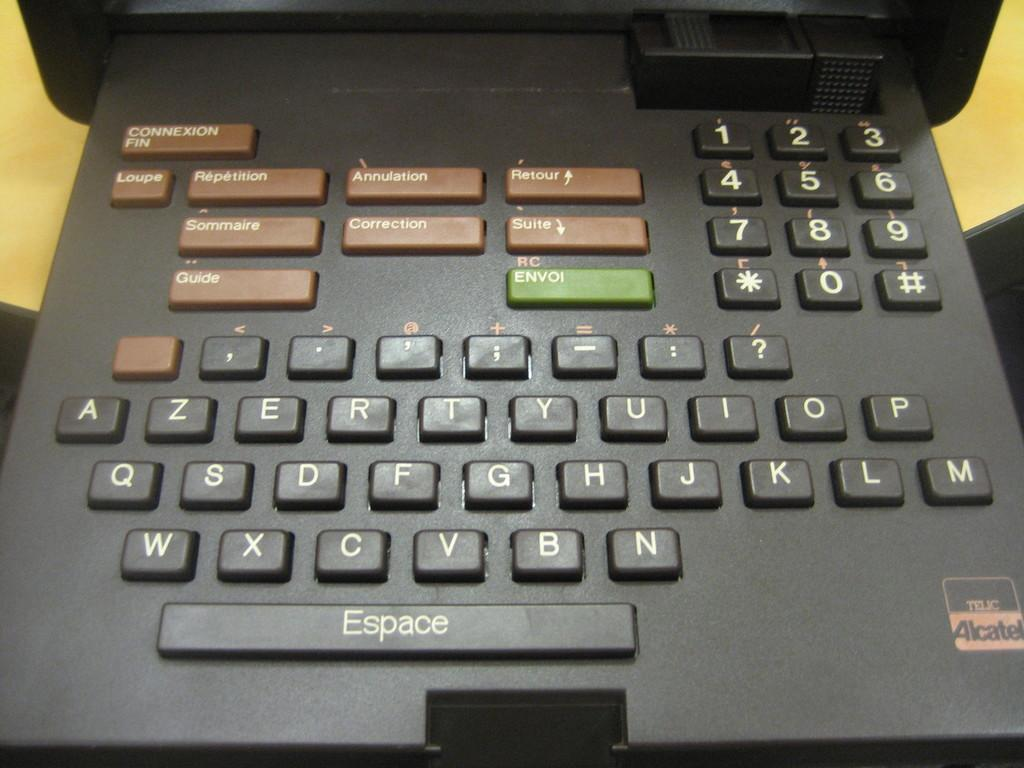<image>
Provide a brief description of the given image. A keyboard has a lot of keys includingpnes for Repetition and Sommaire. 